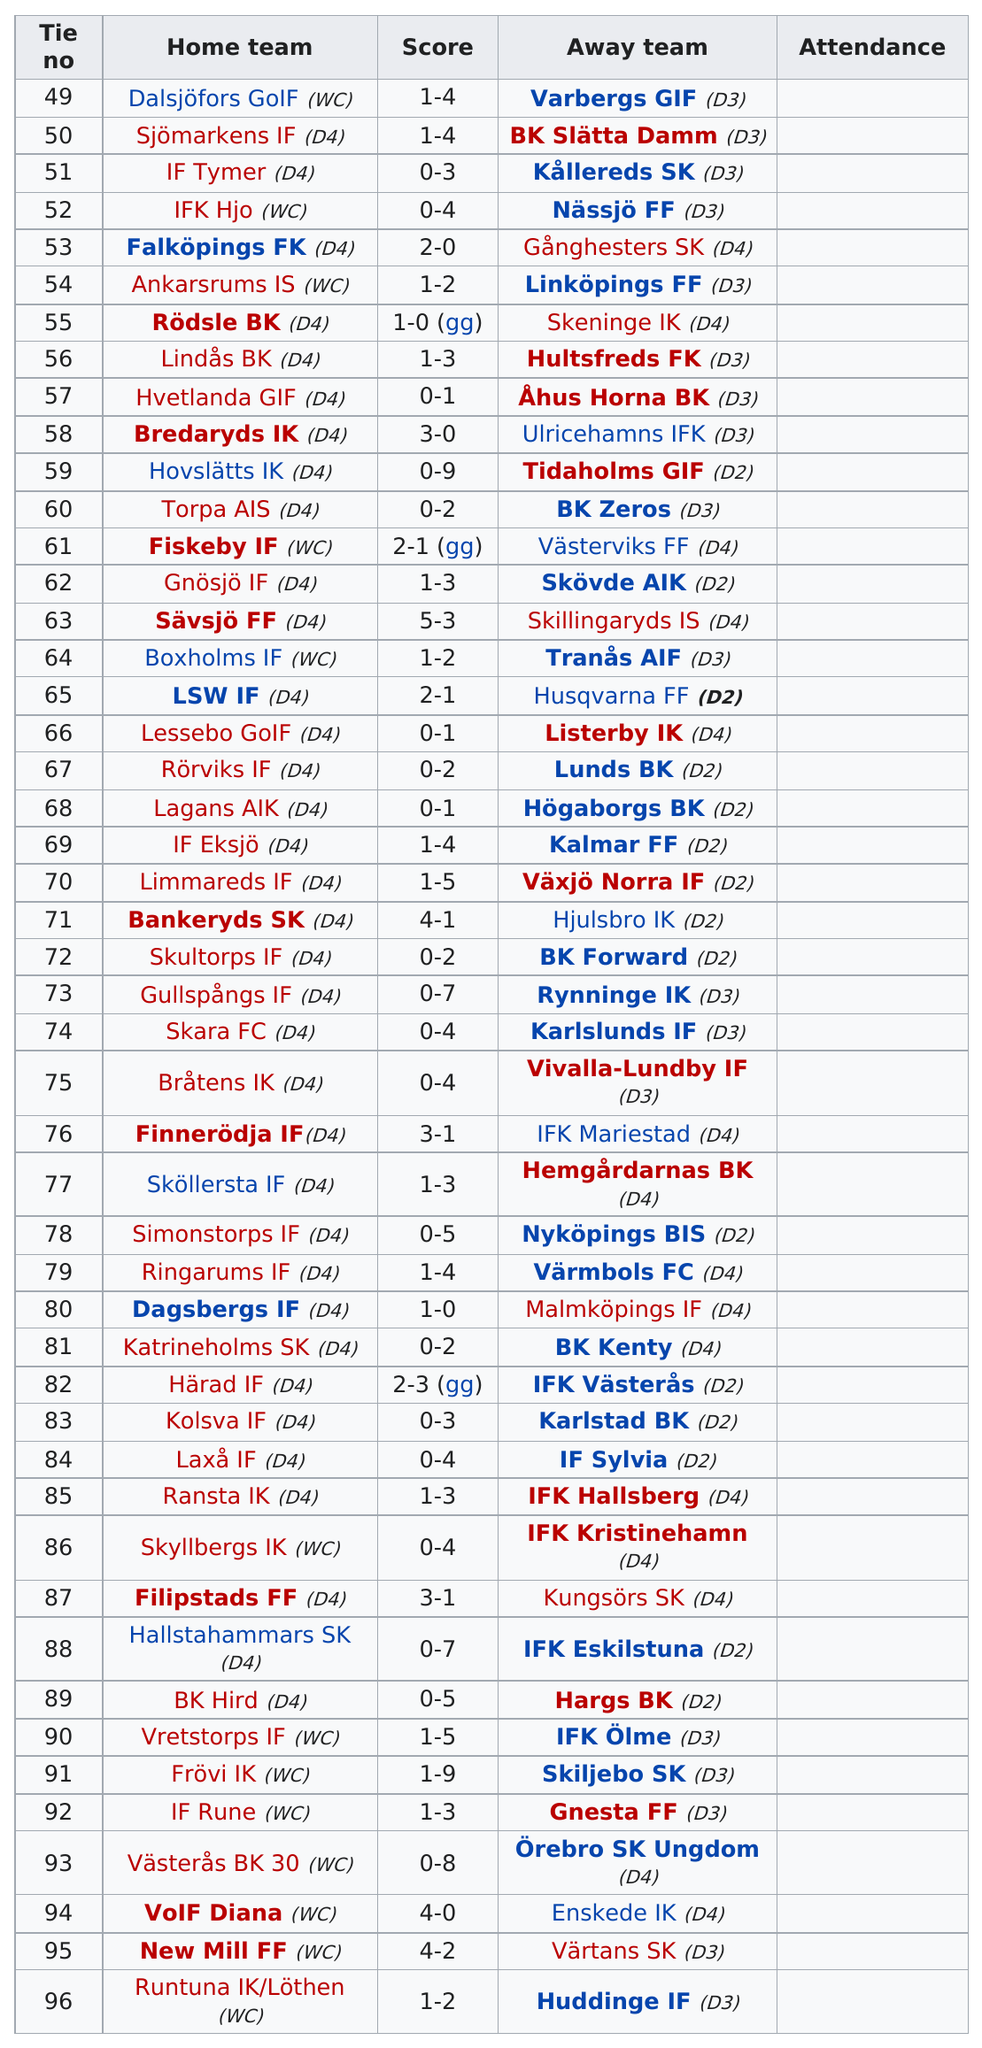Point out several critical features in this image. It is unclear which team is listed as the home team above IFK Hjo. IFK stands for "Innebandy Föreningen Kamratförening" which translates to "Ice Hockey Club Fellowship Club" in English. It is possible that the team listed as the home team is IFK Hjo, as they are an ice hockey club based in Hjo, Sweden. However, without additional information it is impossible to confirm this. What comes after Fiskeby if Gnösjö IF is considered? Out of the 25 teams that played, how many teams scored no points against their opponents? The first away team listed on the chart is Varbergs GIF. Falköpings FK has won against the away team, making it the first home team listed in the records. 